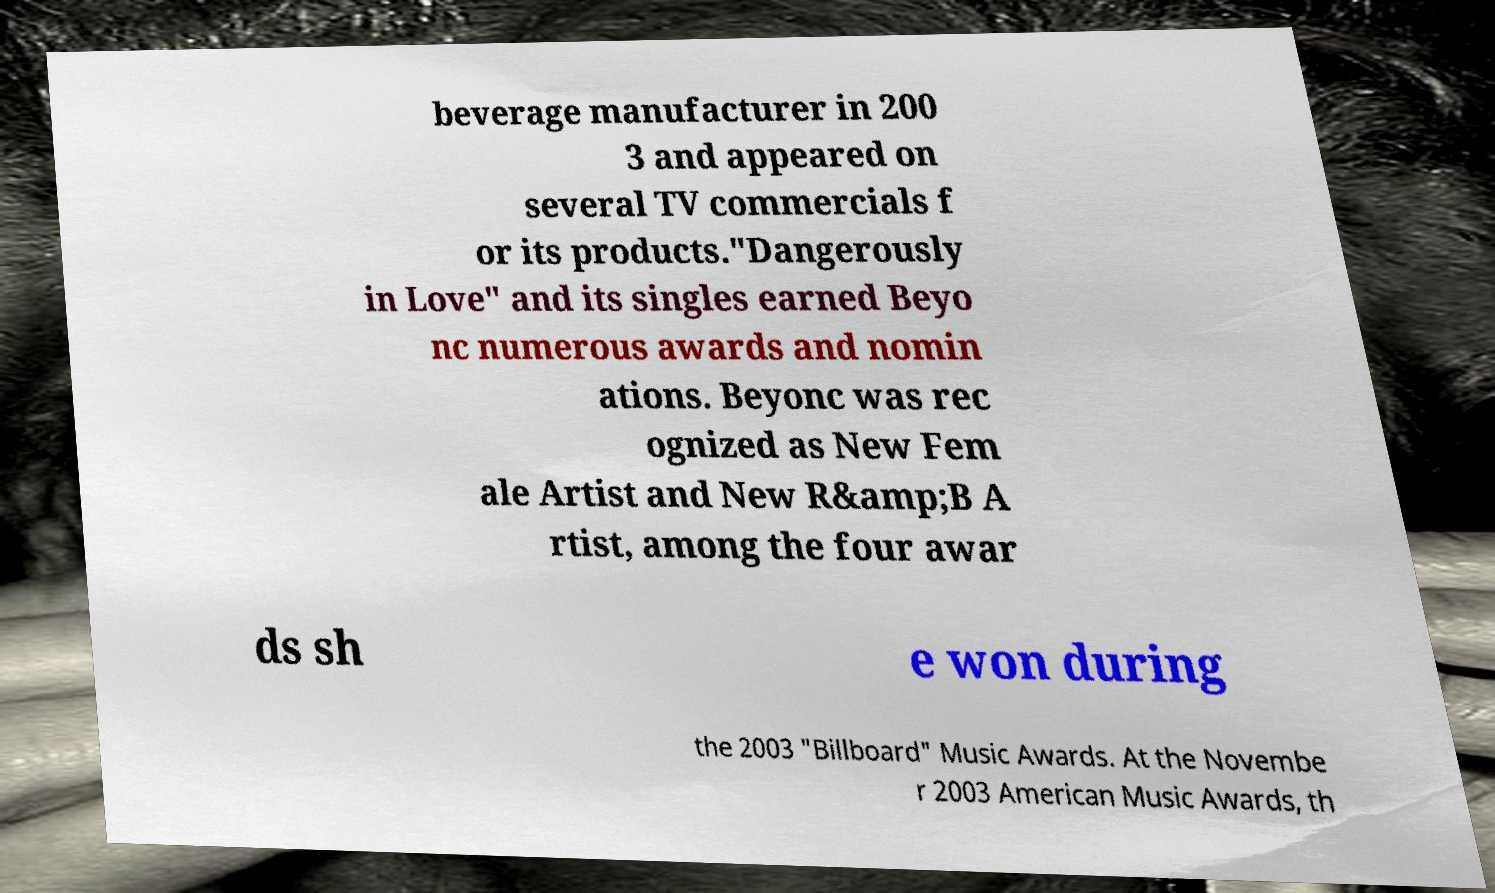Can you accurately transcribe the text from the provided image for me? beverage manufacturer in 200 3 and appeared on several TV commercials f or its products."Dangerously in Love" and its singles earned Beyo nc numerous awards and nomin ations. Beyonc was rec ognized as New Fem ale Artist and New R&amp;B A rtist, among the four awar ds sh e won during the 2003 "Billboard" Music Awards. At the Novembe r 2003 American Music Awards, th 